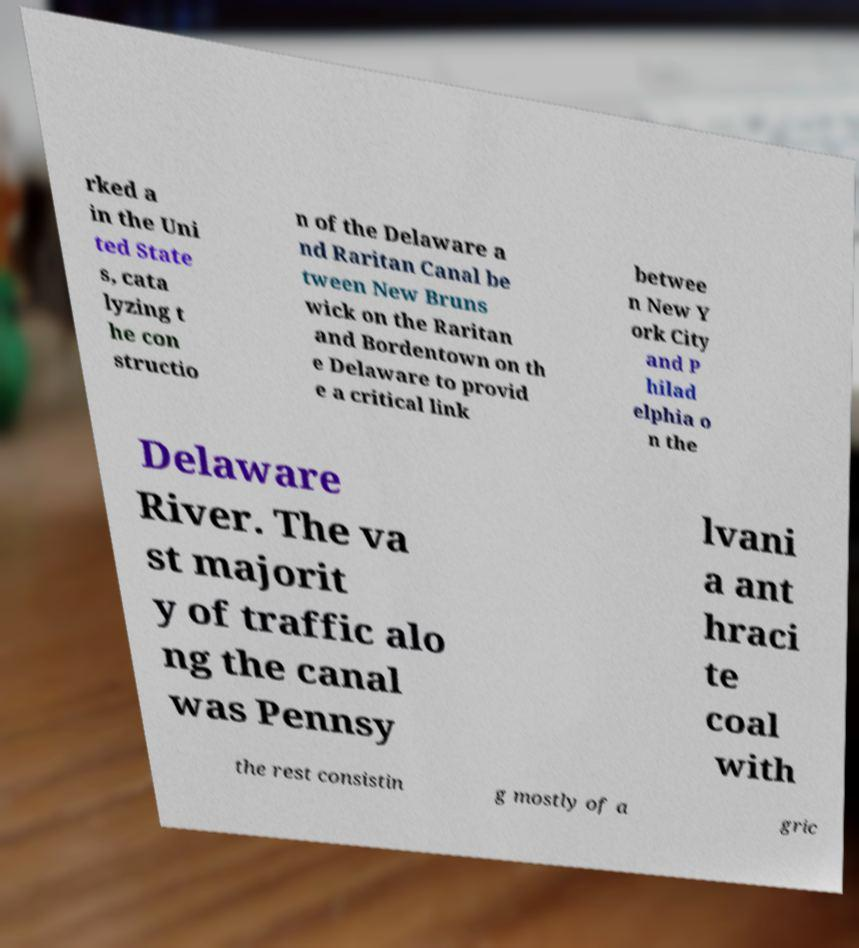Could you extract and type out the text from this image? rked a in the Uni ted State s, cata lyzing t he con structio n of the Delaware a nd Raritan Canal be tween New Bruns wick on the Raritan and Bordentown on th e Delaware to provid e a critical link betwee n New Y ork City and P hilad elphia o n the Delaware River. The va st majorit y of traffic alo ng the canal was Pennsy lvani a ant hraci te coal with the rest consistin g mostly of a gric 